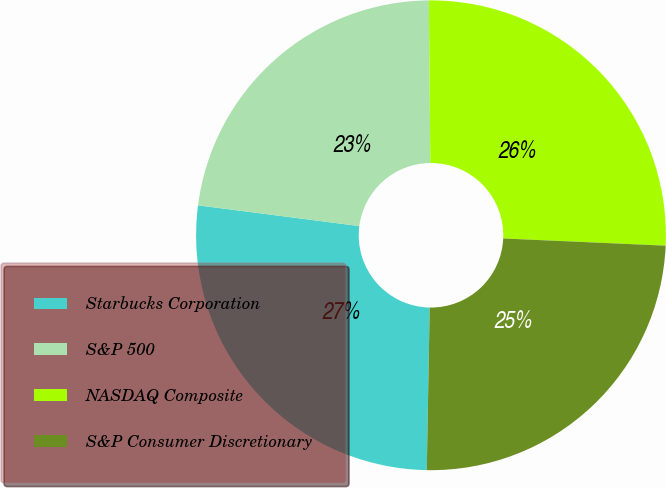Convert chart. <chart><loc_0><loc_0><loc_500><loc_500><pie_chart><fcel>Starbucks Corporation<fcel>S&P 500<fcel>NASDAQ Composite<fcel>S&P Consumer Discretionary<nl><fcel>26.75%<fcel>22.82%<fcel>25.85%<fcel>24.58%<nl></chart> 